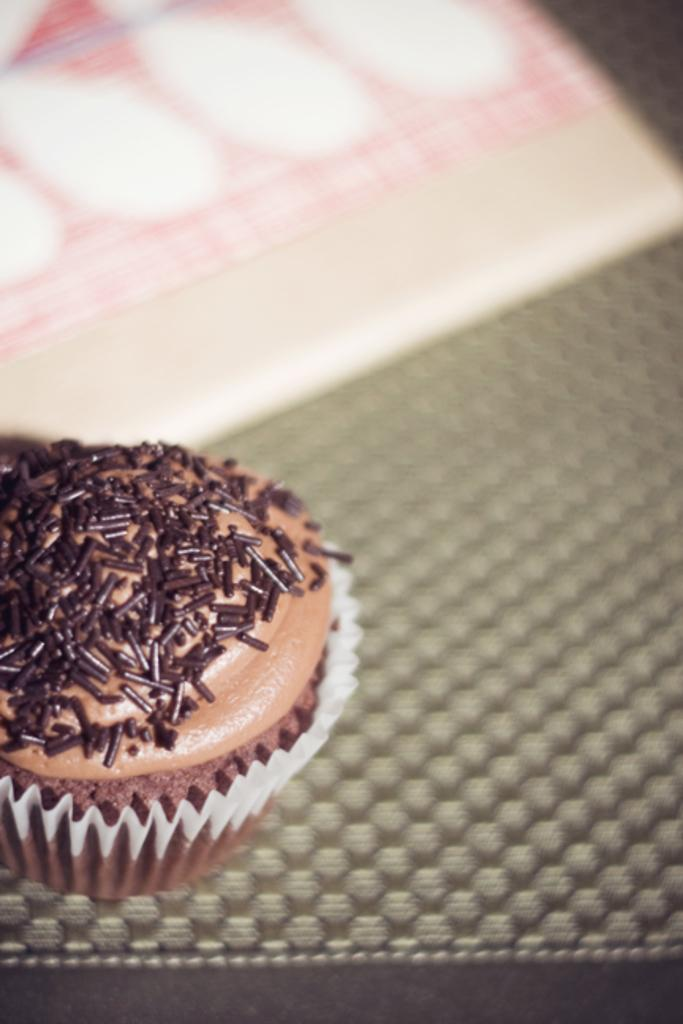What type of food is visible in the image? There is a cupcake in the image. Where is the cupcake located? The cupcake is placed on a surface. How many children are playing with the wren in the image? There are no children or wrens present in the image; it only features a cupcake on a surface. 